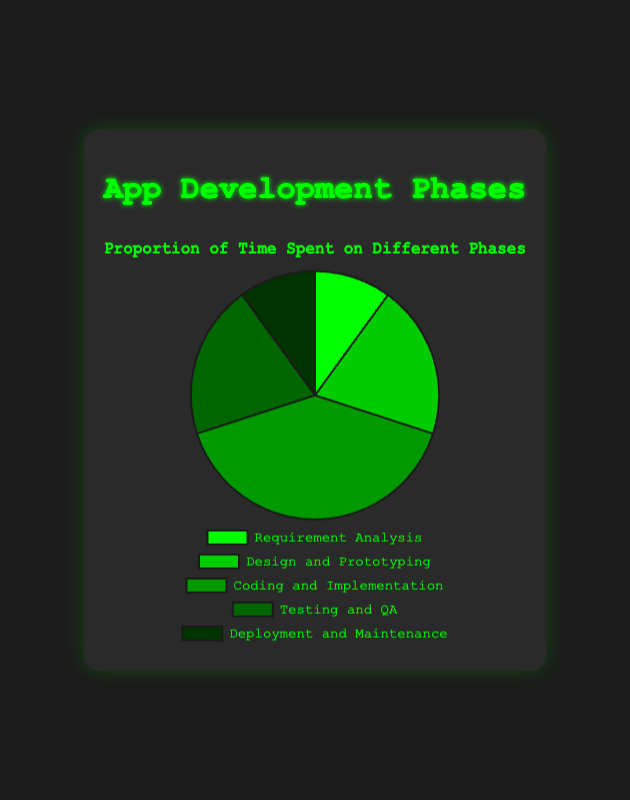Which development phase takes up the largest proportion of time? The chart shows that the "Coding and Implementation" phase has the largest segment, representing 40% of the total time spent.
Answer: Coding and Implementation How much more time is spent on "Design and Prototyping" compared to "Requirement Analysis"? "Design and Prototyping" takes up 20% of the time, while "Requirement Analysis" takes up 10%. The difference is 20% - 10% = 10%.
Answer: 10% Is the time spent on "Testing and QA" equal to the time spent on "Design and Prototyping"? The chart indicates that both "Testing and QA" and "Design and Prototyping" take up 20% of the time each.
Answer: Yes What is the combined proportion of time spent on "Requirement Analysis" and "Deployment and Maintenance"? "Requirement Analysis" and "Deployment and Maintenance" both take up 10% each. Their combined time is 10% + 10% = 20%.
Answer: 20% Compare the time spent on "Coding and Implementation" to the sum of time spent on "Requirement Analysis" and "Deployment and Maintenance". "Coding and Implementation" takes up 40% of the time. "Requirement Analysis" and "Deployment and Maintenance" together take up 10% + 10% = 20%. Therefore, 40% is greater than 20%.
Answer: Greater Which phase uses the darkest green shade in the chart? The "Deployment and Maintenance" phase uses the darkest green shade in the chart.
Answer: Deployment and Maintenance What is the average proportion of time spent across all development phases? The proportions are 10%, 20%, 40%, 20%, and 10%. The average is calculated as (10 + 20 + 40 + 20 + 10) / 5 = 100 / 5 = 20%.
Answer: 20% What proportion of time is spent on phases other than "Coding and Implementation"? The time spent on other phases is computed by subtracting the "Coding and Implementation" time from 100%. Therefore, 100% - 40% = 60%.
Answer: 60% What is the difference in time spent between the most time-consuming phase and the least time-consuming phase? The most time-consuming phase is "Coding and Implementation" with 40%, and the least time-consuming phases are "Requirement Analysis" and "Deployment and Maintenance", each with 10%. The difference is 40% - 10% = 30%.
Answer: 30% 